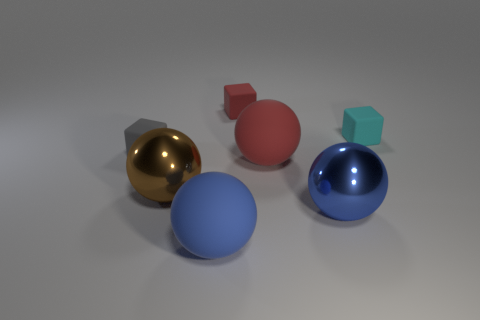What is the color of the large matte thing that is right of the small red rubber cube?
Ensure brevity in your answer.  Red. Is there a red ball that has the same size as the red block?
Keep it short and to the point. No. What material is the cyan object that is the same size as the red block?
Provide a succinct answer. Rubber. Does the brown metal thing have the same size as the metallic object on the right side of the big blue matte ball?
Provide a short and direct response. Yes. There is a big sphere that is on the left side of the blue matte sphere; what is it made of?
Your answer should be very brief. Metal. Is the number of small objects to the right of the brown shiny ball the same as the number of big brown objects?
Make the answer very short. No. Is the red sphere the same size as the brown shiny ball?
Your answer should be very brief. Yes. Is there a brown sphere on the left side of the large blue metallic object that is in front of the cyan matte thing that is right of the large blue metal object?
Offer a terse response. Yes. There is a large brown thing that is the same shape as the blue matte thing; what is its material?
Offer a very short reply. Metal. What number of matte blocks are to the right of the large metal sphere in front of the big brown thing?
Your answer should be compact. 1. 